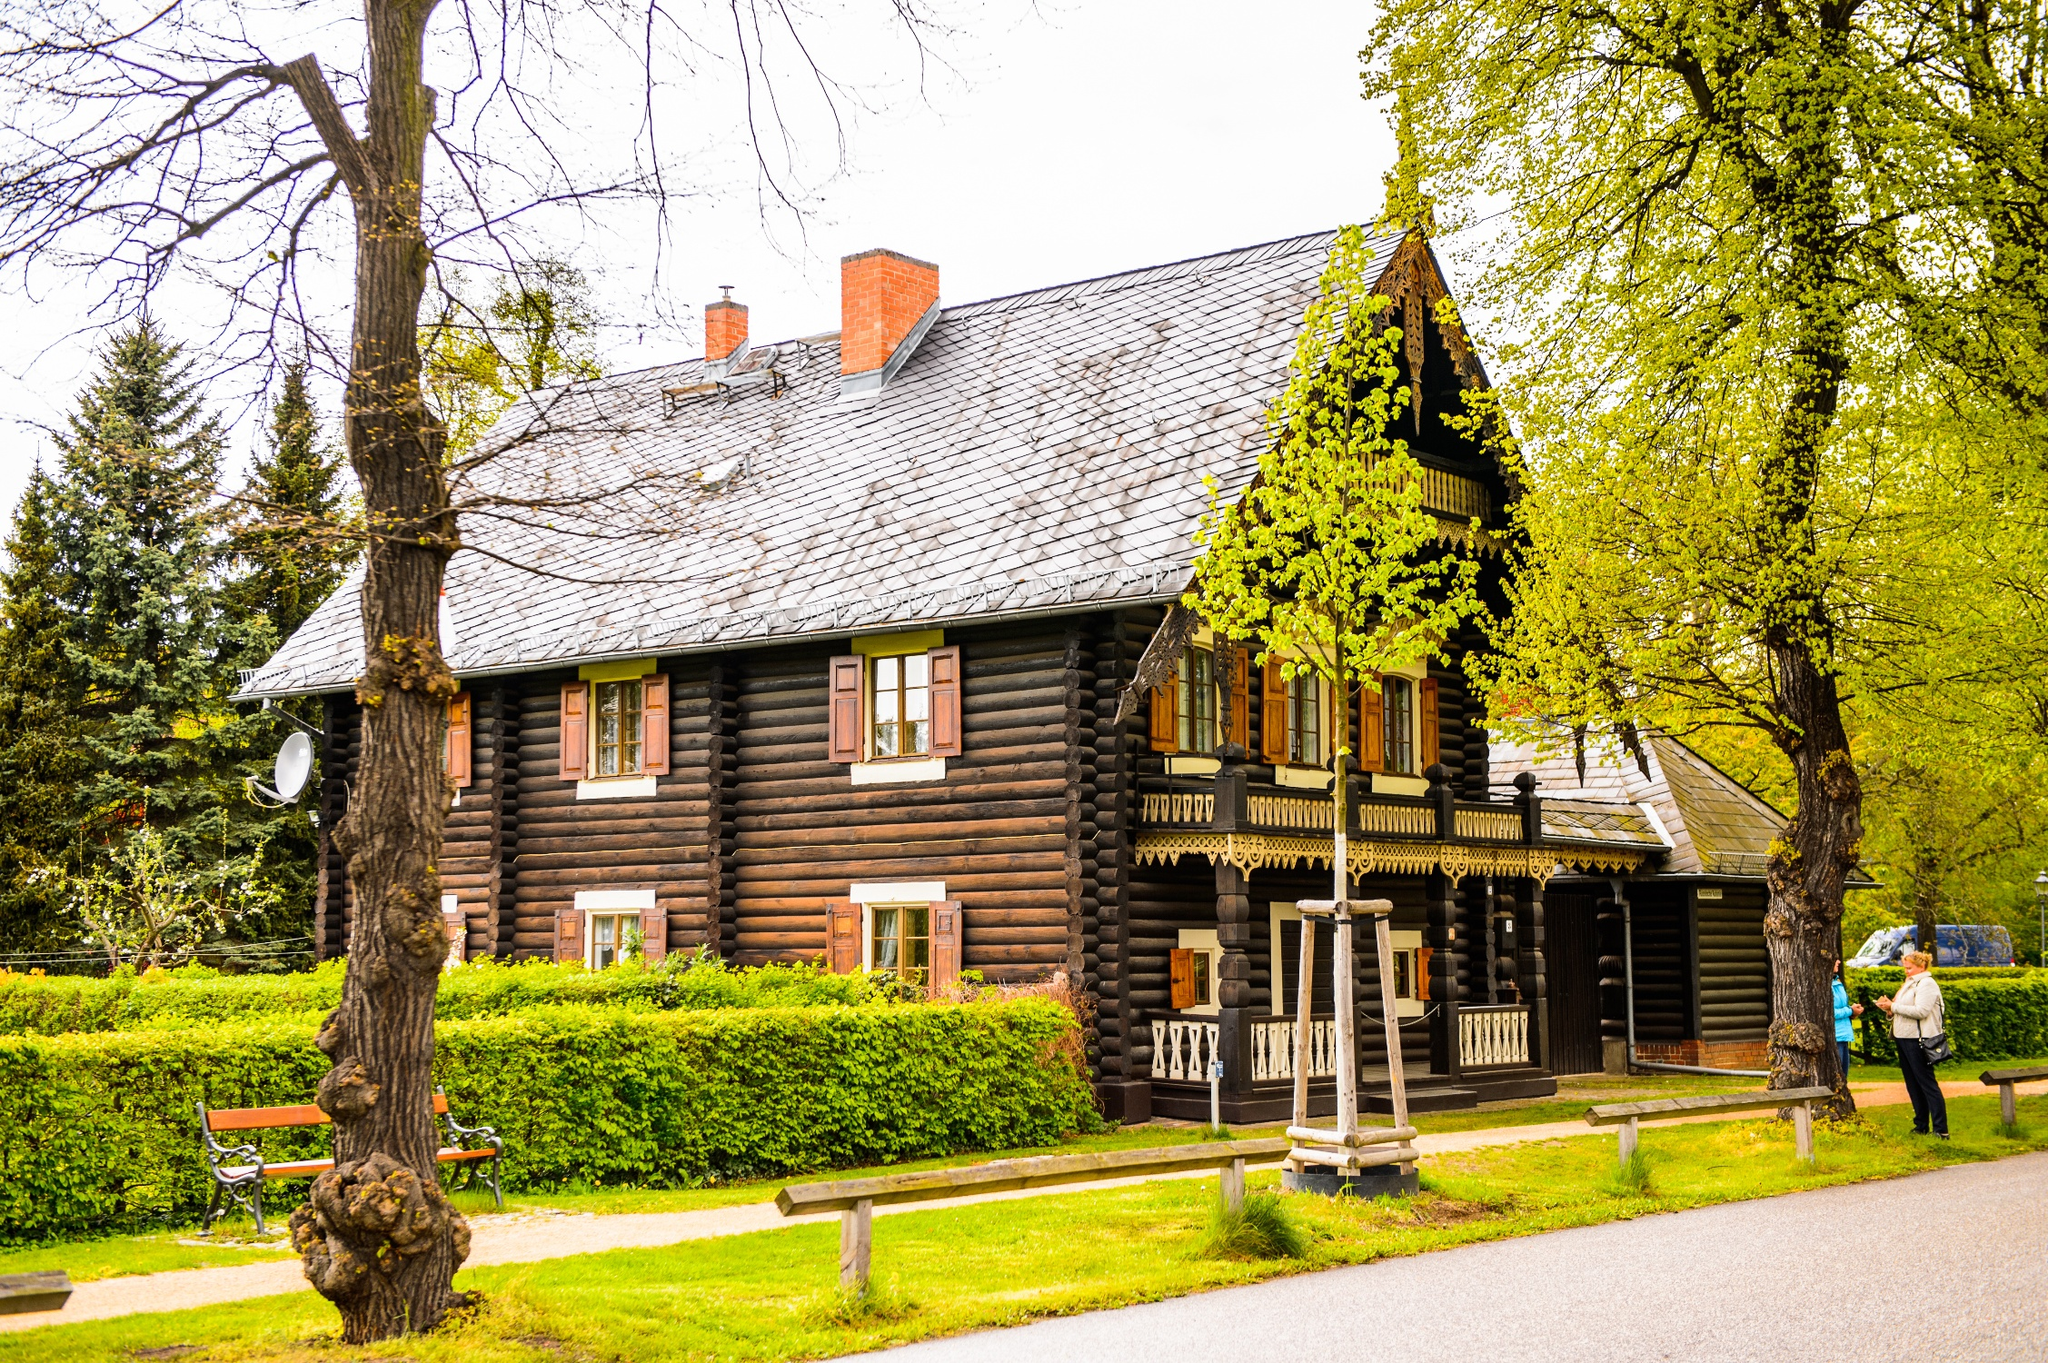Can you describe the natural setting surrounding the house and explain how it might affect the living experience in this cabin? The cabin is nestled within a vibrant, verdant landscape, likely offering a tranquil and secluded living experience. The surrounding lush greenery, which includes mature trees and well-manicured hedges, provides not only scenic beauty but also privacy and a buffer from the outside world. The proximity to nature could facilitate a peaceful retreat environment, ideal for relaxation or creative pursuits. Such a setting is also conducive to outdoor activities like walking or picnicking, directly accessible via the paths leading around and away from the cabin. The overall impact on living experience would be one of calm, connection to nature, and perhaps a sense of timelessness. 